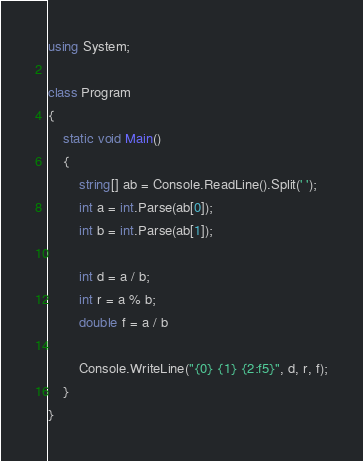Convert code to text. <code><loc_0><loc_0><loc_500><loc_500><_C#_>using System;

class Program
{
    static void Main()
    {
        string[] ab = Console.ReadLine().Split(' ');
        int a = int.Parse(ab[0]);
        int b = int.Parse(ab[1]);

        int d = a / b;
        int r = a % b;
        double f = a / b

        Console.WriteLine("{0} {1} {2:f5}", d, r, f);
    }
}</code> 